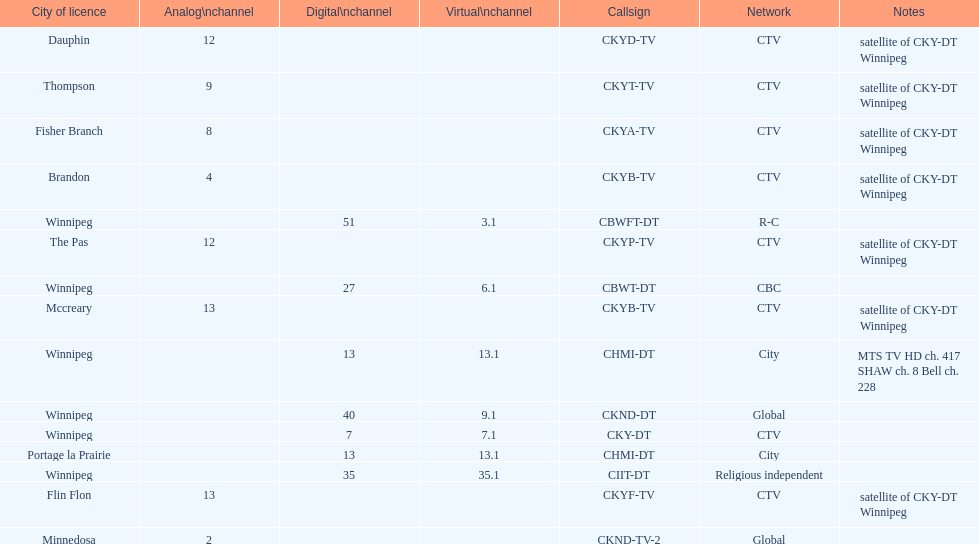Which network has the most satellite stations? CTV. 